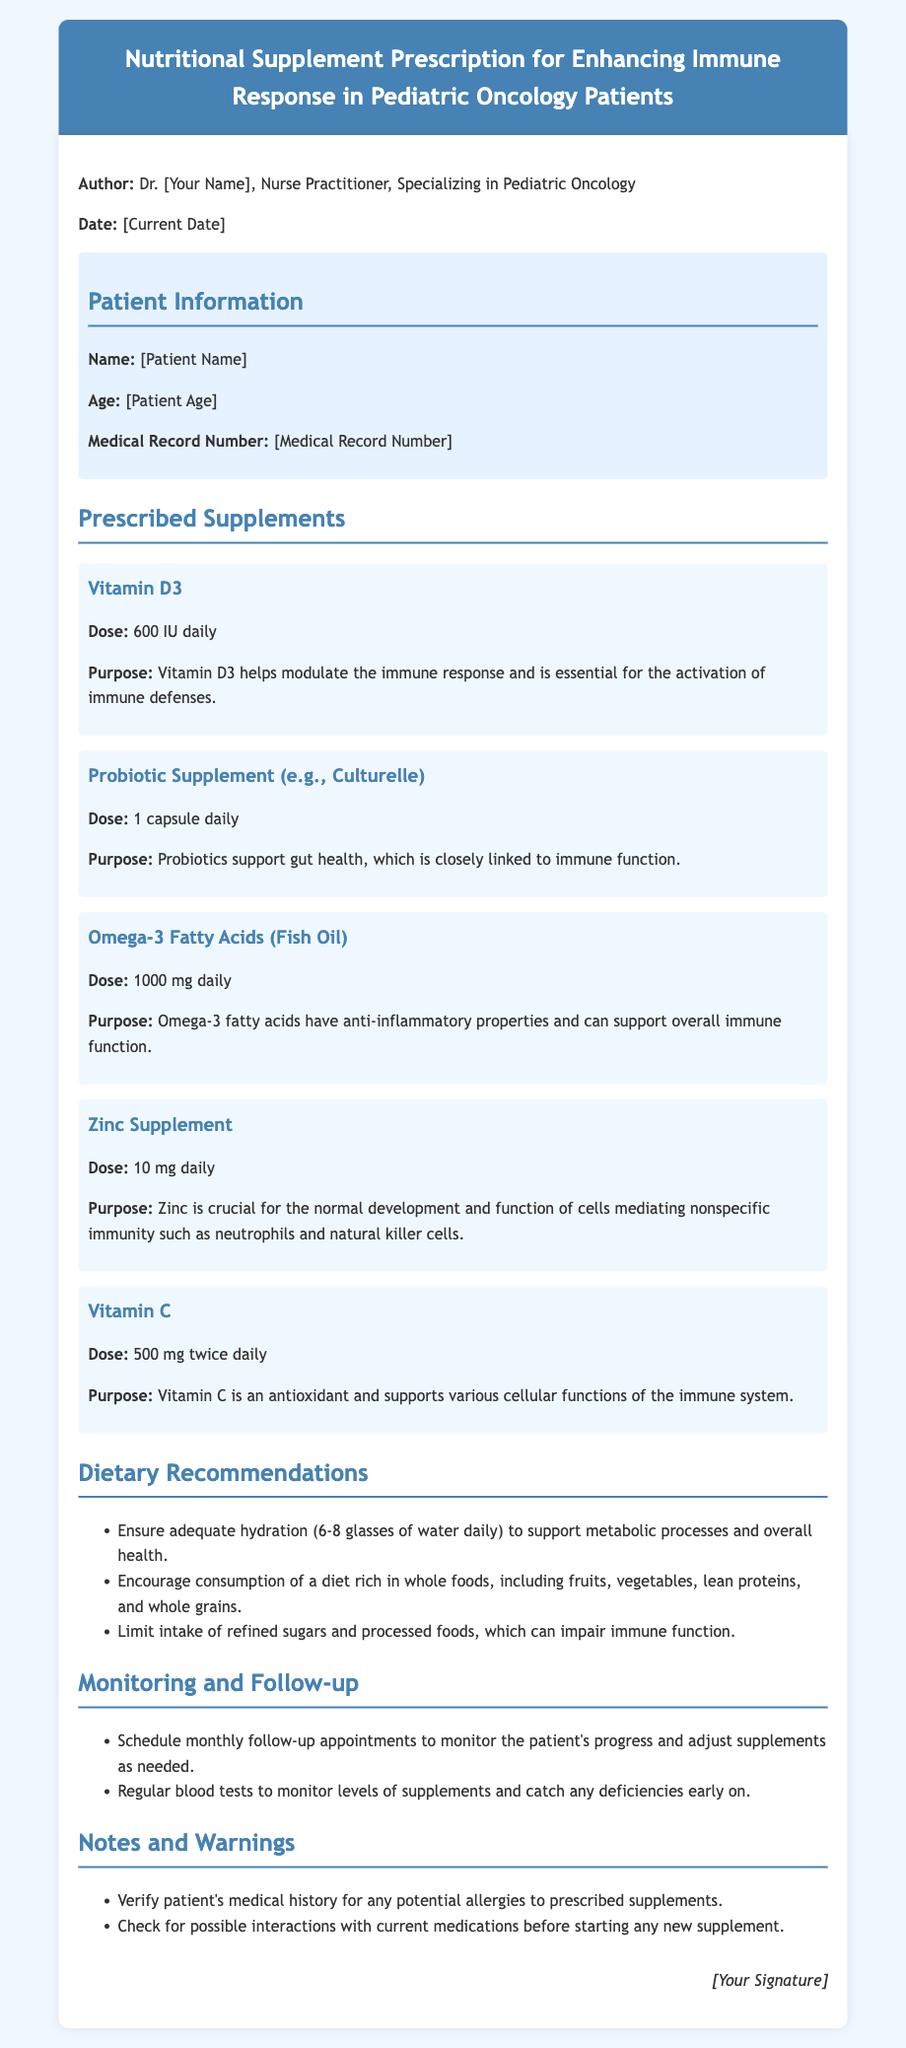What is the name of the author? The author's name is provided in the document, clearly stated under the author section.
Answer: Dr. [Your Name] What is the date of the prescription? The date is indicated in the document and is formatted in a standard manner.
Answer: [Current Date] How much Vitamin D3 is prescribed? The dosage of Vitamin D3 is specified directly in the document under the prescribed supplements section.
Answer: 600 IU daily What is the purpose of Zinc Supplement? The document includes a specific purpose for each supplement, including Zinc.
Answer: Crucial for the normal development of cells mediating nonspecific immunity How often should Vitamin C be taken? The document specifies the recommended intake frequency for Vitamin C in the dosage section.
Answer: 500 mg twice daily How many glasses of water should be consumed daily? The dietary recommendations in the document mention hydration needs.
Answer: 6-8 glasses What type of follow-up appointments are recommended? The monitoring section of the document outlines the recommended scheduling of appointments.
Answer: Monthly follow-up appointments What should be checked for potential allergies? The notes section mentions an important precaution regarding allergies to supplements.
Answer: Patient's medical history Which probiotic is mentioned in the prescription? The document names a specific probiotic supplement under the prescribed supplements section.
Answer: Culturelle 